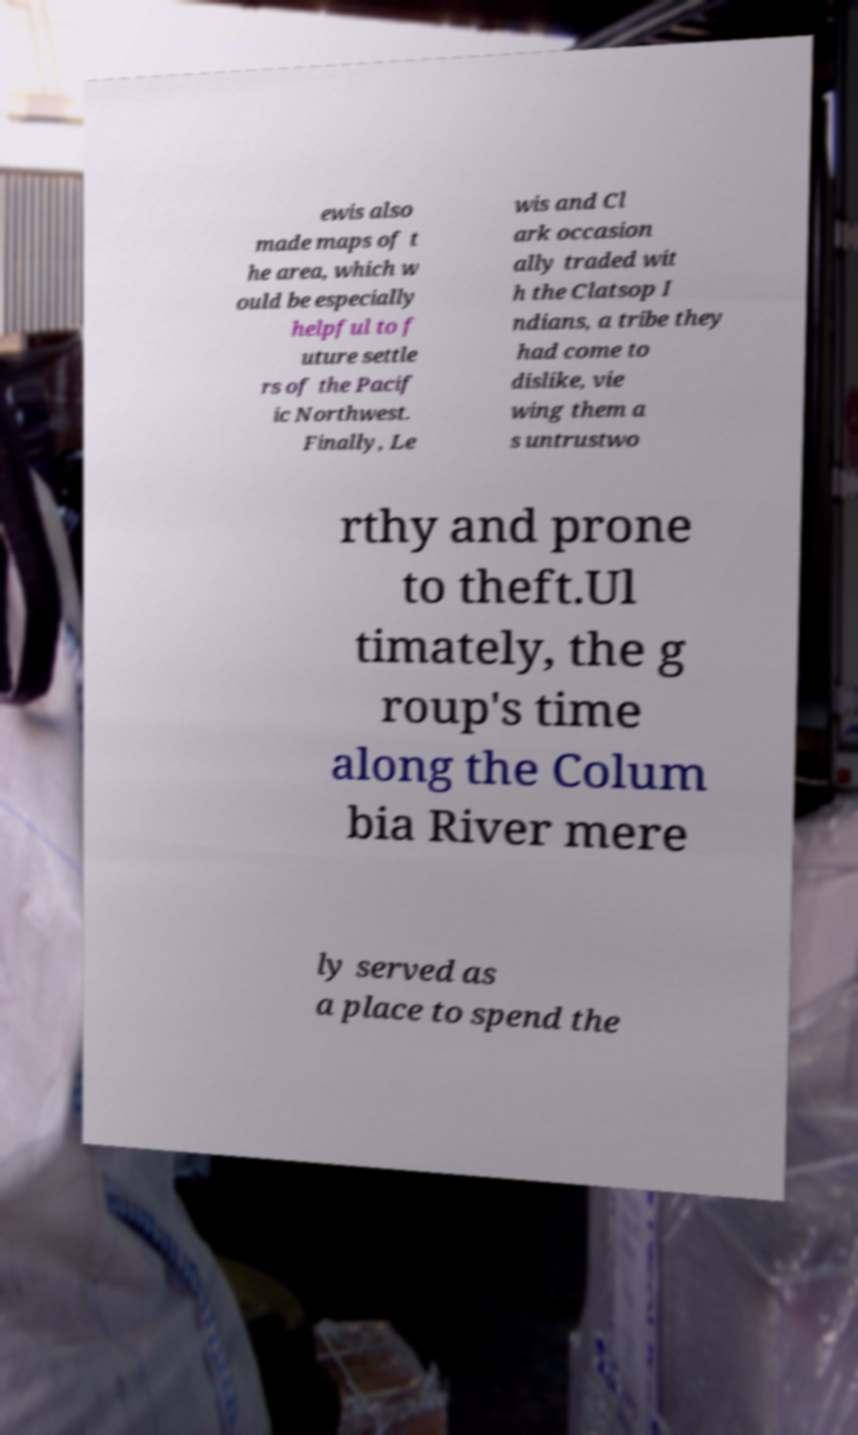There's text embedded in this image that I need extracted. Can you transcribe it verbatim? ewis also made maps of t he area, which w ould be especially helpful to f uture settle rs of the Pacif ic Northwest. Finally, Le wis and Cl ark occasion ally traded wit h the Clatsop I ndians, a tribe they had come to dislike, vie wing them a s untrustwo rthy and prone to theft.Ul timately, the g roup's time along the Colum bia River mere ly served as a place to spend the 